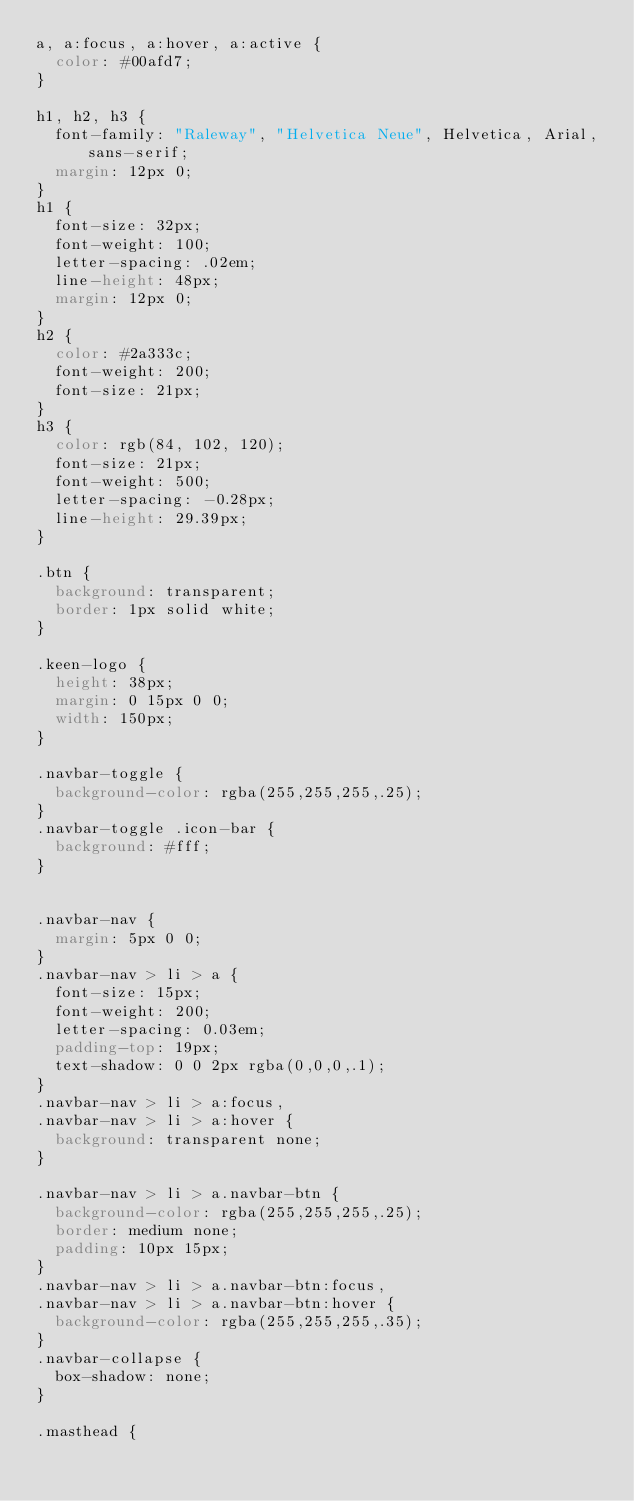<code> <loc_0><loc_0><loc_500><loc_500><_CSS_>a, a:focus, a:hover, a:active {
  color: #00afd7;
}

h1, h2, h3 {
  font-family: "Raleway", "Helvetica Neue", Helvetica, Arial, sans-serif;
  margin: 12px 0;
}
h1 {
  font-size: 32px;
  font-weight: 100;
  letter-spacing: .02em;
  line-height: 48px;
  margin: 12px 0;
}
h2 {
  color: #2a333c;
  font-weight: 200;
  font-size: 21px;
}
h3 {
  color: rgb(84, 102, 120);
  font-size: 21px;
  font-weight: 500;
  letter-spacing: -0.28px;
  line-height: 29.39px;
}

.btn {
  background: transparent;
  border: 1px solid white;
}

.keen-logo {
  height: 38px;
  margin: 0 15px 0 0;
  width: 150px;
}

.navbar-toggle {
  background-color: rgba(255,255,255,.25);
}
.navbar-toggle .icon-bar {
  background: #fff;
}


.navbar-nav {
  margin: 5px 0 0;
}
.navbar-nav > li > a {
  font-size: 15px;
  font-weight: 200;
  letter-spacing: 0.03em;
  padding-top: 19px;
  text-shadow: 0 0 2px rgba(0,0,0,.1);
}
.navbar-nav > li > a:focus,
.navbar-nav > li > a:hover {
  background: transparent none;
}

.navbar-nav > li > a.navbar-btn {
  background-color: rgba(255,255,255,.25);
  border: medium none;
  padding: 10px 15px;
}
.navbar-nav > li > a.navbar-btn:focus,
.navbar-nav > li > a.navbar-btn:hover {
  background-color: rgba(255,255,255,.35);
}
.navbar-collapse {
  box-shadow: none;
}

.masthead {</code> 